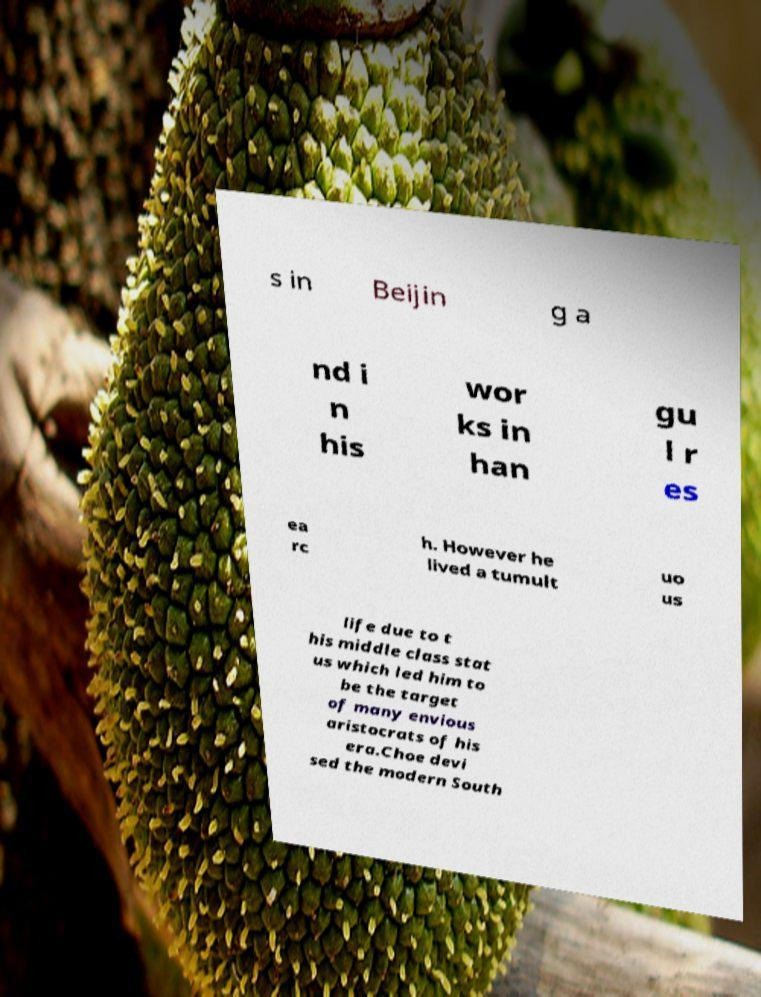For documentation purposes, I need the text within this image transcribed. Could you provide that? s in Beijin g a nd i n his wor ks in han gu l r es ea rc h. However he lived a tumult uo us life due to t his middle class stat us which led him to be the target of many envious aristocrats of his era.Choe devi sed the modern South 